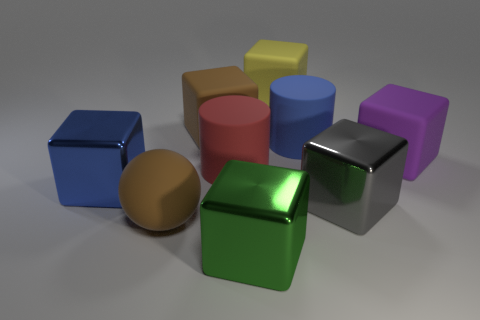Can you describe the texture and material of the objects in the image? The objects appear to have a matte finish with a slight sheen, suggesting that they are made of a material similar to plastic or painted metal. The lighting reveals their smooth surfaces and rounded edges. 